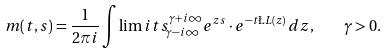Convert formula to latex. <formula><loc_0><loc_0><loc_500><loc_500>m ( t , s ) = \frac { 1 } { 2 \pi i } \int \lim i t s _ { \gamma - i \infty } ^ { \gamma + i \infty } e ^ { z s } \cdot e ^ { - t \L L ( z ) } \, d z , \quad \gamma > 0 .</formula> 